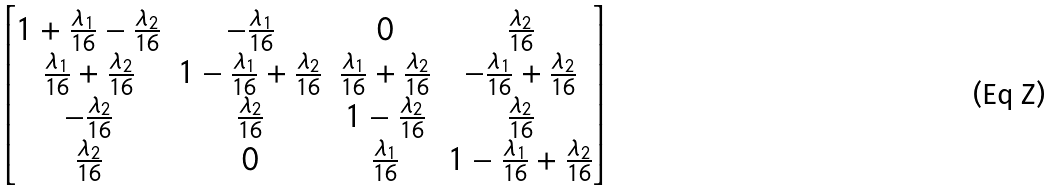<formula> <loc_0><loc_0><loc_500><loc_500>\begin{bmatrix} 1 + \frac { \lambda _ { 1 } } { 1 6 } - \frac { \lambda _ { 2 } } { 1 6 } & - \frac { \lambda _ { 1 } } { 1 6 } & 0 & \frac { \lambda _ { 2 } } { 1 6 } \\ \frac { \lambda _ { 1 } } { 1 6 } + \frac { \lambda _ { 2 } } { 1 6 } & 1 - \frac { \lambda _ { 1 } } { 1 6 } + \frac { \lambda _ { 2 } } { 1 6 } & \frac { \lambda _ { 1 } } { 1 6 } + \frac { \lambda _ { 2 } } { 1 6 } & - \frac { \lambda _ { 1 } } { 1 6 } + \frac { \lambda _ { 2 } } { 1 6 } \\ - \frac { \lambda _ { 2 } } { 1 6 } & \frac { \lambda _ { 2 } } { 1 6 } & 1 - \frac { \lambda _ { 2 } } { 1 6 } & \frac { \lambda _ { 2 } } { 1 6 } \\ \frac { \lambda _ { 2 } } { 1 6 } & 0 & \frac { \lambda _ { 1 } } { 1 6 } & 1 - \frac { \lambda _ { 1 } } { 1 6 } + \frac { \lambda _ { 2 } } { 1 6 } \end{bmatrix}</formula> 